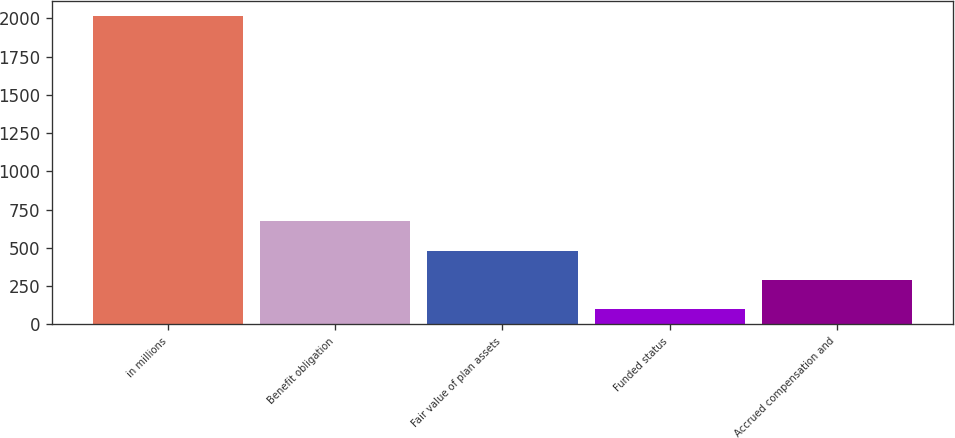<chart> <loc_0><loc_0><loc_500><loc_500><bar_chart><fcel>in millions<fcel>Benefit obligation<fcel>Fair value of plan assets<fcel>Funded status<fcel>Accrued compensation and<nl><fcel>2014<fcel>673.92<fcel>482.48<fcel>99.6<fcel>291.04<nl></chart> 